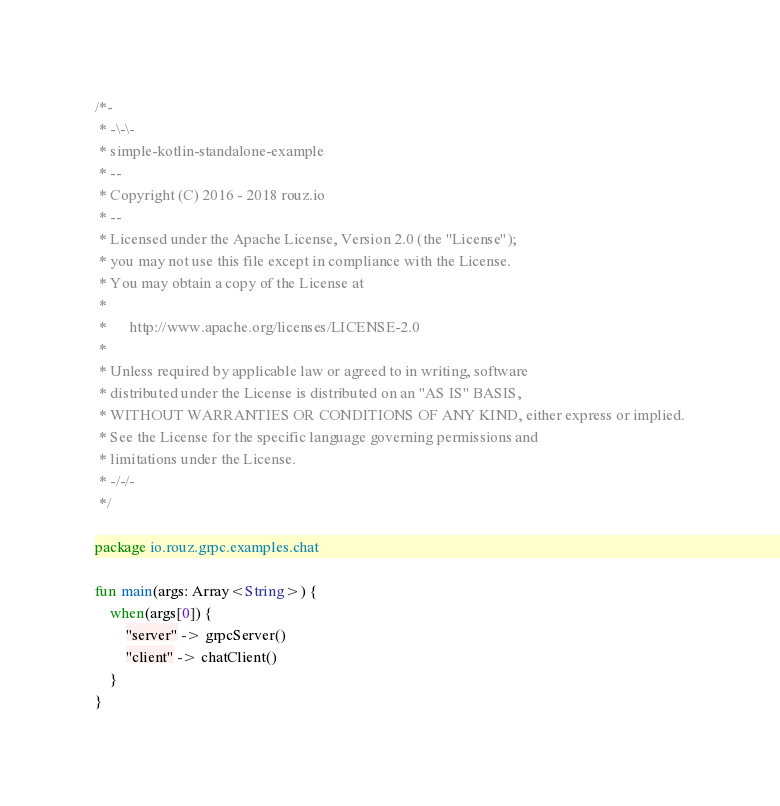Convert code to text. <code><loc_0><loc_0><loc_500><loc_500><_Kotlin_>/*-
 * -\-\-
 * simple-kotlin-standalone-example
 * --
 * Copyright (C) 2016 - 2018 rouz.io
 * --
 * Licensed under the Apache License, Version 2.0 (the "License");
 * you may not use this file except in compliance with the License.
 * You may obtain a copy of the License at
 * 
 *      http://www.apache.org/licenses/LICENSE-2.0
 * 
 * Unless required by applicable law or agreed to in writing, software
 * distributed under the License is distributed on an "AS IS" BASIS,
 * WITHOUT WARRANTIES OR CONDITIONS OF ANY KIND, either express or implied.
 * See the License for the specific language governing permissions and
 * limitations under the License.
 * -/-/-
 */

package io.rouz.grpc.examples.chat

fun main(args: Array<String>) {
    when(args[0]) {
        "server" -> grpcServer()
        "client" -> chatClient()
    }
}
</code> 